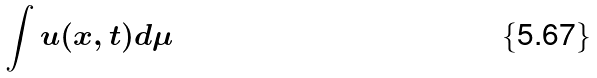Convert formula to latex. <formula><loc_0><loc_0><loc_500><loc_500>\int u ( x , t ) d \mu</formula> 